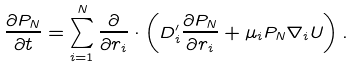Convert formula to latex. <formula><loc_0><loc_0><loc_500><loc_500>\frac { \partial P _ { N } } { \partial t } = \sum _ { i = 1 } ^ { N } \frac { \partial } { \partial r _ { i } } \cdot \left ( D ^ { \prime } _ { i } \frac { \partial P _ { N } } { \partial r _ { i } } + \mu _ { i } { P _ { N } } \nabla _ { i } U \right ) .</formula> 